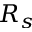Convert formula to latex. <formula><loc_0><loc_0><loc_500><loc_500>R _ { s }</formula> 